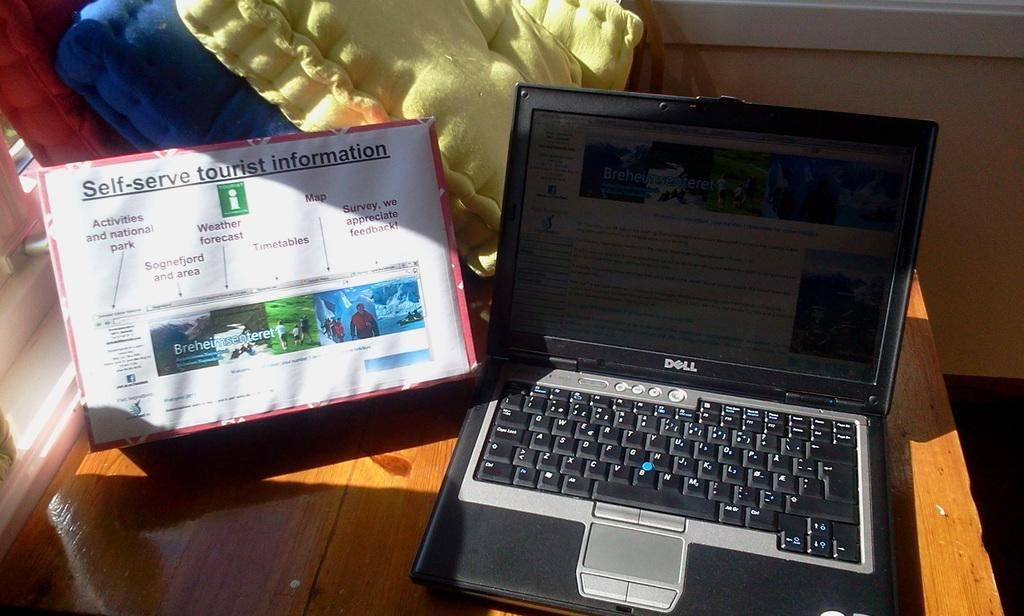What is the main piece of furniture in the image? There is a table in the image. What electronic device is on the table? A laptop is present on the table. What other items can be seen on the table? There is a board and cushions visible on the table. What can be seen in the background of the image? There is a wall and a window in the background of the image. Where was the image taken? The image was taken in a hall. How many pancakes are stacked on the table in the image? There are no pancakes present in the image. What type of footwear is visible on the person in the image? There is no person visible in the image, so no footwear can be observed. 